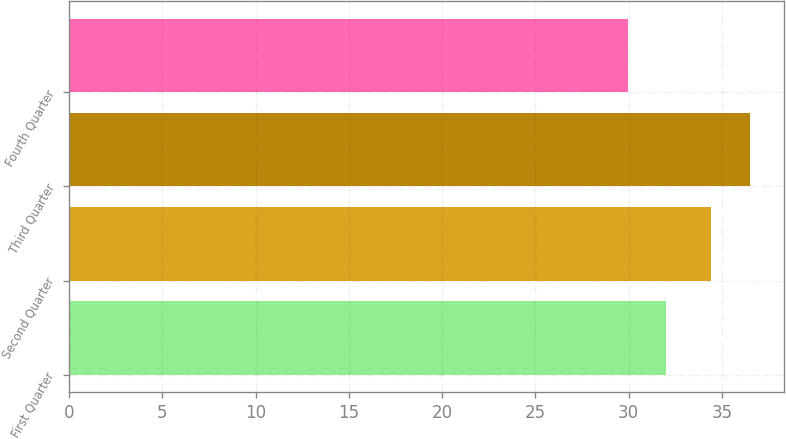Convert chart. <chart><loc_0><loc_0><loc_500><loc_500><bar_chart><fcel>First Quarter<fcel>Second Quarter<fcel>Third Quarter<fcel>Fourth Quarter<nl><fcel>32<fcel>34.44<fcel>36.52<fcel>29.96<nl></chart> 